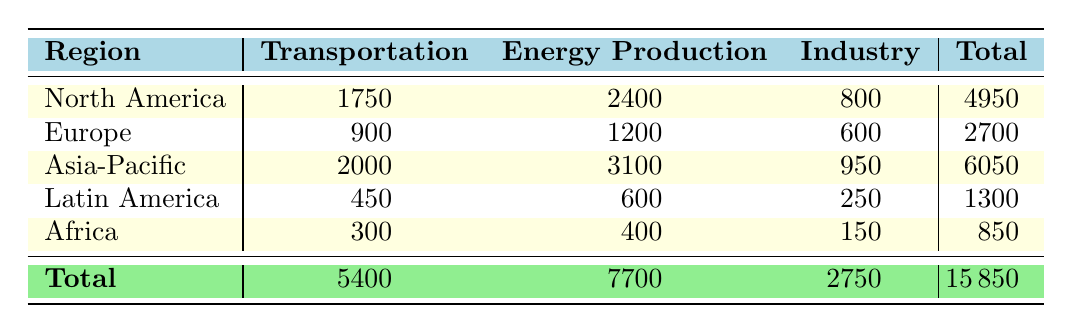What is the total carbon emissions from the Transportation sector in North America? Referring to the "Transportation" column for North America, the value is 1750. Thus, the total carbon emissions from this sector in North America is 1750.
Answer: 1750 Which region has the highest carbon emissions from Energy Production? Looking at the "Energy Production" column across all regions, Asia-Pacific has the highest value of 3100.
Answer: Asia-Pacific What is the total carbon emissions from all sectors in Latin America? Summing the values in each sector for Latin America: 450 (Transportation) + 600 (Energy Production) + 250 (Industry) = 1300.
Answer: 1300 Is the total carbon emissions from the Industry sector in Asia-Pacific greater than the total from the same sector in Europe? The total for Asia-Pacific in the Industry sector is 950 and for Europe, it is 600. Since 950 is greater than 600, the statement is true.
Answer: Yes What is the average carbon emissions from the Transportation sector across all regions? The total for Transportation is 5400 from all regions. There are five regions, so the average is 5400 divided by 5, which equals 1080.
Answer: 1080 How much more carbon emissions does North America produce in Energy Production than Africa? Energy Production emissions for North America are 2400 and for Africa, it is 400. The difference is 2400 - 400 = 2000.
Answer: 2000 What percentage of the total carbon emissions do the emissions from the Transportation sector represent in North America? The total emissions in North America is 4950. The emissions from Transportation are 1750. The percentage is (1750/4950) * 100 = approximately 35.35%.
Answer: 35.35% Are carbon emissions from the Transportation sector in Europe more than in Africa? Transportation emissions for Europe are 900 and for Africa, they are 300. Since 900 is greater than 300, the statement is true.
Answer: Yes What is the total carbon emissions from Industry in all regions combined? Summing the values from the Industry sector: 800 (North America) + 600 (Europe) + 950 (Asia-Pacific) + 250 (Latin America) + 150 (Africa) results in a total of 2750.
Answer: 2750 